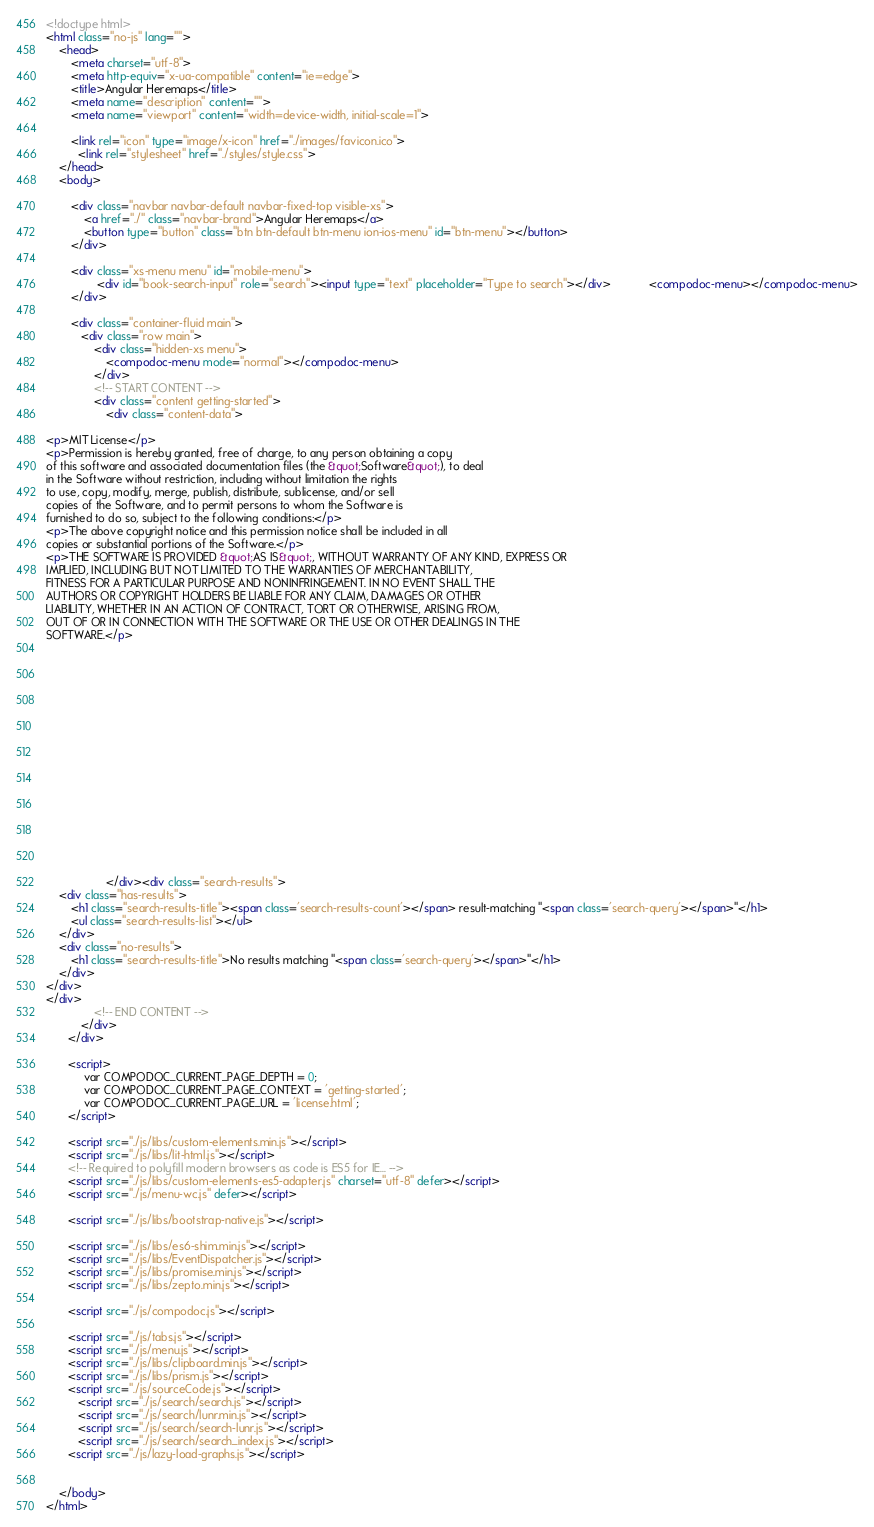Convert code to text. <code><loc_0><loc_0><loc_500><loc_500><_HTML_><!doctype html>
<html class="no-js" lang="">
    <head>
        <meta charset="utf-8">
        <meta http-equiv="x-ua-compatible" content="ie=edge">
        <title>Angular Heremaps</title>
        <meta name="description" content="">
        <meta name="viewport" content="width=device-width, initial-scale=1">

        <link rel="icon" type="image/x-icon" href="./images/favicon.ico">
	      <link rel="stylesheet" href="./styles/style.css">
    </head>
    <body>

        <div class="navbar navbar-default navbar-fixed-top visible-xs">
            <a href="./" class="navbar-brand">Angular Heremaps</a>
            <button type="button" class="btn btn-default btn-menu ion-ios-menu" id="btn-menu"></button>
        </div>

        <div class="xs-menu menu" id="mobile-menu">
                <div id="book-search-input" role="search"><input type="text" placeholder="Type to search"></div>            <compodoc-menu></compodoc-menu>
        </div>

        <div class="container-fluid main">
           <div class="row main">
               <div class="hidden-xs menu">
                   <compodoc-menu mode="normal"></compodoc-menu>
               </div>
               <!-- START CONTENT -->
               <div class="content getting-started">
                   <div class="content-data">

<p>MIT License</p>
<p>Permission is hereby granted, free of charge, to any person obtaining a copy
of this software and associated documentation files (the &quot;Software&quot;), to deal
in the Software without restriction, including without limitation the rights
to use, copy, modify, merge, publish, distribute, sublicense, and/or sell
copies of the Software, and to permit persons to whom the Software is
furnished to do so, subject to the following conditions:</p>
<p>The above copyright notice and this permission notice shall be included in all
copies or substantial portions of the Software.</p>
<p>THE SOFTWARE IS PROVIDED &quot;AS IS&quot;, WITHOUT WARRANTY OF ANY KIND, EXPRESS OR
IMPLIED, INCLUDING BUT NOT LIMITED TO THE WARRANTIES OF MERCHANTABILITY,
FITNESS FOR A PARTICULAR PURPOSE AND NONINFRINGEMENT. IN NO EVENT SHALL THE
AUTHORS OR COPYRIGHT HOLDERS BE LIABLE FOR ANY CLAIM, DAMAGES OR OTHER
LIABILITY, WHETHER IN AN ACTION OF CONTRACT, TORT OR OTHERWISE, ARISING FROM,
OUT OF OR IN CONNECTION WITH THE SOFTWARE OR THE USE OR OTHER DEALINGS IN THE
SOFTWARE.</p>


















                   </div><div class="search-results">
    <div class="has-results">
        <h1 class="search-results-title"><span class='search-results-count'></span> result-matching "<span class='search-query'></span>"</h1>
        <ul class="search-results-list"></ul>
    </div>
    <div class="no-results">
        <h1 class="search-results-title">No results matching "<span class='search-query'></span>"</h1>
    </div>
</div>
</div>
               <!-- END CONTENT -->
           </div>
       </div>

       <script>
            var COMPODOC_CURRENT_PAGE_DEPTH = 0;
            var COMPODOC_CURRENT_PAGE_CONTEXT = 'getting-started';
            var COMPODOC_CURRENT_PAGE_URL = 'license.html';
       </script>

       <script src="./js/libs/custom-elements.min.js"></script>
       <script src="./js/libs/lit-html.js"></script>
       <!-- Required to polyfill modern browsers as code is ES5 for IE... -->
       <script src="./js/libs/custom-elements-es5-adapter.js" charset="utf-8" defer></script>
       <script src="./js/menu-wc.js" defer></script>

       <script src="./js/libs/bootstrap-native.js"></script>

       <script src="./js/libs/es6-shim.min.js"></script>
       <script src="./js/libs/EventDispatcher.js"></script>
       <script src="./js/libs/promise.min.js"></script>
       <script src="./js/libs/zepto.min.js"></script>

       <script src="./js/compodoc.js"></script>

       <script src="./js/tabs.js"></script>
       <script src="./js/menu.js"></script>
       <script src="./js/libs/clipboard.min.js"></script>
       <script src="./js/libs/prism.js"></script>
       <script src="./js/sourceCode.js"></script>
          <script src="./js/search/search.js"></script>
          <script src="./js/search/lunr.min.js"></script>
          <script src="./js/search/search-lunr.js"></script>
          <script src="./js/search/search_index.js"></script>
       <script src="./js/lazy-load-graphs.js"></script>


    </body>
</html>
</code> 